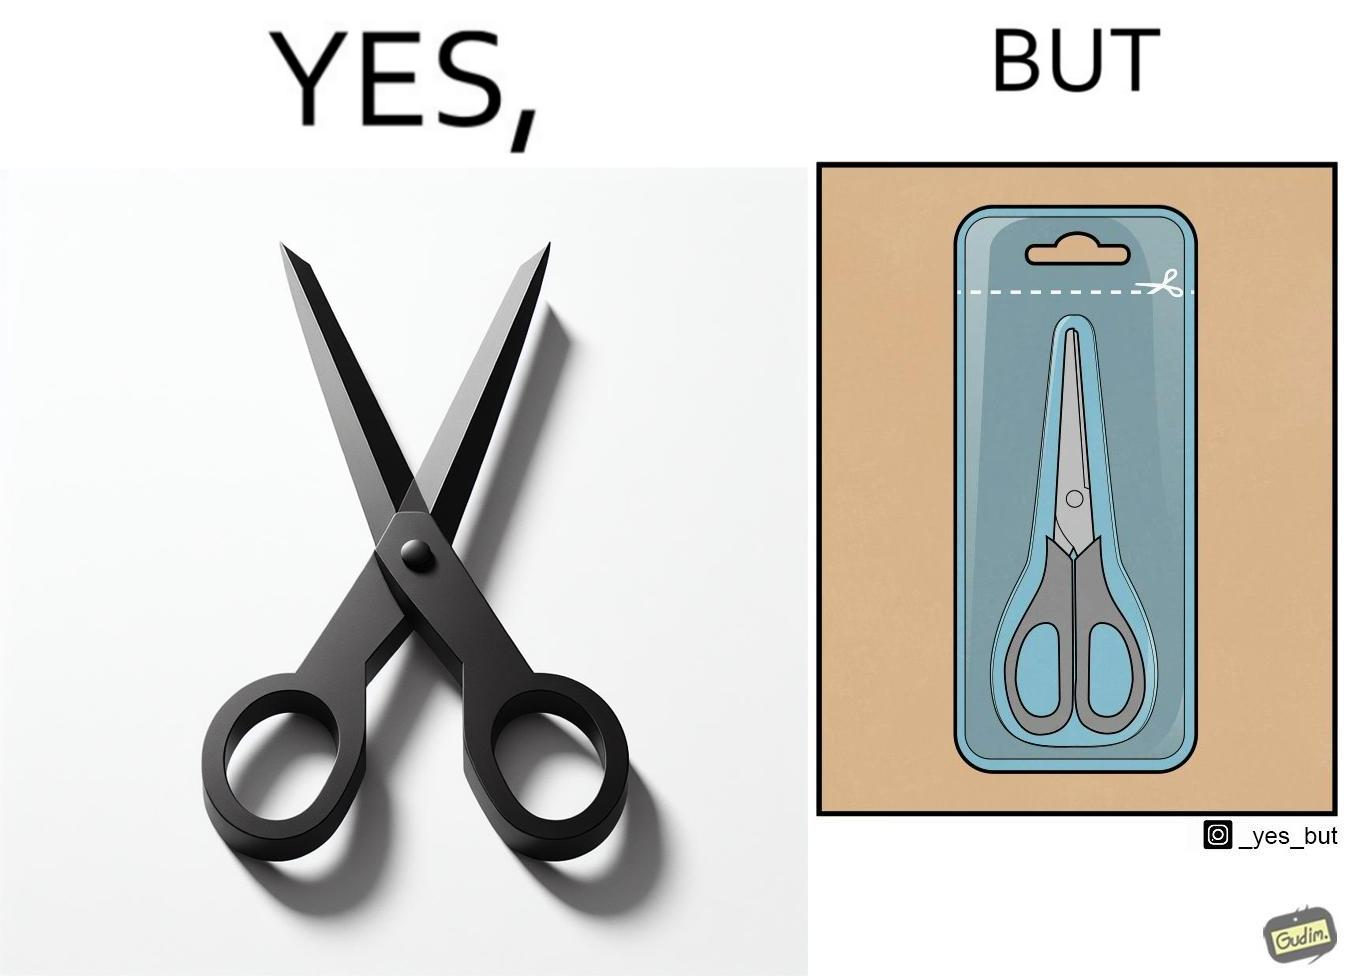Describe the contrast between the left and right parts of this image. In the left part of the image: a pair of scissors In the right part of the image: a pair of scissors inside a packaging, with a marking at the top showing that you would need to open it using a pair of scissors. 